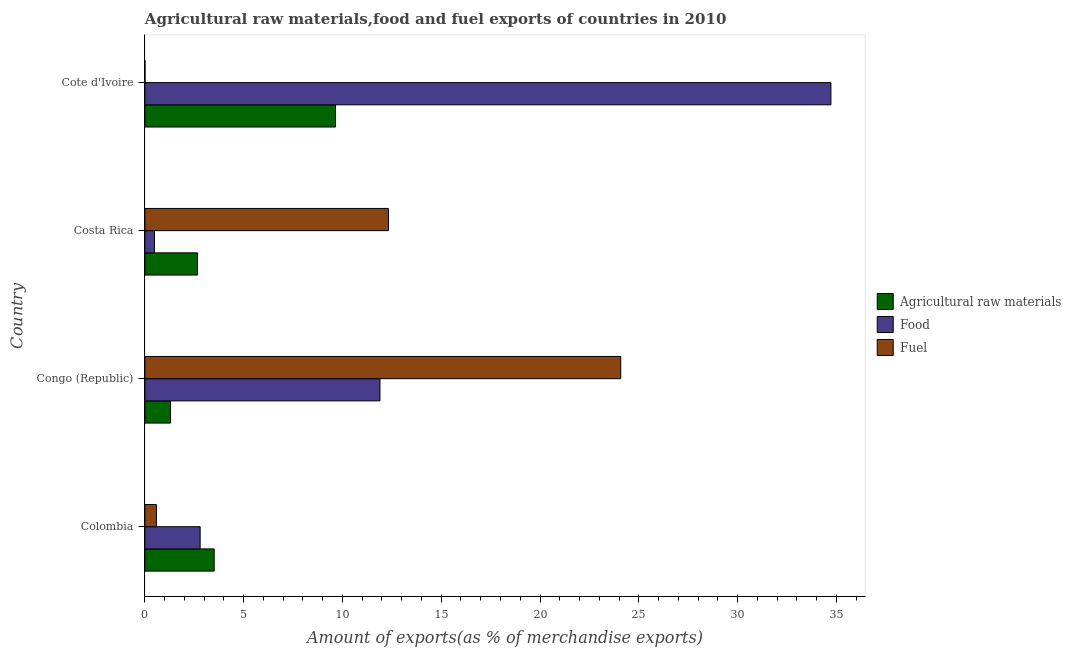How many different coloured bars are there?
Your answer should be compact. 3. Are the number of bars on each tick of the Y-axis equal?
Make the answer very short. Yes. In how many cases, is the number of bars for a given country not equal to the number of legend labels?
Give a very brief answer. 0. What is the percentage of food exports in Congo (Republic)?
Provide a short and direct response. 11.9. Across all countries, what is the maximum percentage of raw materials exports?
Offer a terse response. 9.65. Across all countries, what is the minimum percentage of fuel exports?
Give a very brief answer. 0. In which country was the percentage of raw materials exports maximum?
Your answer should be compact. Cote d'Ivoire. In which country was the percentage of raw materials exports minimum?
Make the answer very short. Congo (Republic). What is the total percentage of food exports in the graph?
Give a very brief answer. 49.9. What is the difference between the percentage of raw materials exports in Colombia and that in Congo (Republic)?
Offer a very short reply. 2.21. What is the difference between the percentage of raw materials exports in Colombia and the percentage of fuel exports in Cote d'Ivoire?
Provide a succinct answer. 3.5. What is the average percentage of fuel exports per country?
Offer a very short reply. 9.25. What is the difference between the percentage of raw materials exports and percentage of fuel exports in Colombia?
Ensure brevity in your answer.  2.92. What is the ratio of the percentage of fuel exports in Colombia to that in Costa Rica?
Offer a terse response. 0.05. Is the percentage of fuel exports in Colombia less than that in Costa Rica?
Provide a short and direct response. Yes. What is the difference between the highest and the second highest percentage of fuel exports?
Ensure brevity in your answer.  11.76. What is the difference between the highest and the lowest percentage of fuel exports?
Your answer should be very brief. 24.08. In how many countries, is the percentage of raw materials exports greater than the average percentage of raw materials exports taken over all countries?
Your response must be concise. 1. What does the 3rd bar from the top in Congo (Republic) represents?
Ensure brevity in your answer.  Agricultural raw materials. What does the 1st bar from the bottom in Costa Rica represents?
Your answer should be very brief. Agricultural raw materials. Is it the case that in every country, the sum of the percentage of raw materials exports and percentage of food exports is greater than the percentage of fuel exports?
Provide a short and direct response. No. How many bars are there?
Your response must be concise. 12. How many countries are there in the graph?
Ensure brevity in your answer.  4. Does the graph contain grids?
Ensure brevity in your answer.  No. How many legend labels are there?
Your answer should be very brief. 3. What is the title of the graph?
Offer a very short reply. Agricultural raw materials,food and fuel exports of countries in 2010. Does "Fuel" appear as one of the legend labels in the graph?
Provide a succinct answer. Yes. What is the label or title of the X-axis?
Your answer should be very brief. Amount of exports(as % of merchandise exports). What is the label or title of the Y-axis?
Your response must be concise. Country. What is the Amount of exports(as % of merchandise exports) in Agricultural raw materials in Colombia?
Ensure brevity in your answer.  3.51. What is the Amount of exports(as % of merchandise exports) of Food in Colombia?
Provide a succinct answer. 2.8. What is the Amount of exports(as % of merchandise exports) in Fuel in Colombia?
Provide a succinct answer. 0.58. What is the Amount of exports(as % of merchandise exports) in Agricultural raw materials in Congo (Republic)?
Provide a short and direct response. 1.3. What is the Amount of exports(as % of merchandise exports) of Food in Congo (Republic)?
Offer a very short reply. 11.9. What is the Amount of exports(as % of merchandise exports) in Fuel in Congo (Republic)?
Ensure brevity in your answer.  24.09. What is the Amount of exports(as % of merchandise exports) in Agricultural raw materials in Costa Rica?
Make the answer very short. 2.66. What is the Amount of exports(as % of merchandise exports) in Food in Costa Rica?
Offer a terse response. 0.48. What is the Amount of exports(as % of merchandise exports) of Fuel in Costa Rica?
Provide a succinct answer. 12.33. What is the Amount of exports(as % of merchandise exports) of Agricultural raw materials in Cote d'Ivoire?
Ensure brevity in your answer.  9.65. What is the Amount of exports(as % of merchandise exports) of Food in Cote d'Ivoire?
Your response must be concise. 34.73. What is the Amount of exports(as % of merchandise exports) of Fuel in Cote d'Ivoire?
Your answer should be compact. 0. Across all countries, what is the maximum Amount of exports(as % of merchandise exports) of Agricultural raw materials?
Ensure brevity in your answer.  9.65. Across all countries, what is the maximum Amount of exports(as % of merchandise exports) of Food?
Keep it short and to the point. 34.73. Across all countries, what is the maximum Amount of exports(as % of merchandise exports) in Fuel?
Your answer should be very brief. 24.09. Across all countries, what is the minimum Amount of exports(as % of merchandise exports) in Agricultural raw materials?
Your answer should be compact. 1.3. Across all countries, what is the minimum Amount of exports(as % of merchandise exports) in Food?
Offer a terse response. 0.48. Across all countries, what is the minimum Amount of exports(as % of merchandise exports) of Fuel?
Provide a short and direct response. 0. What is the total Amount of exports(as % of merchandise exports) in Agricultural raw materials in the graph?
Your answer should be compact. 17.11. What is the total Amount of exports(as % of merchandise exports) in Food in the graph?
Your answer should be compact. 49.9. What is the total Amount of exports(as % of merchandise exports) of Fuel in the graph?
Offer a very short reply. 37. What is the difference between the Amount of exports(as % of merchandise exports) in Agricultural raw materials in Colombia and that in Congo (Republic)?
Your answer should be compact. 2.21. What is the difference between the Amount of exports(as % of merchandise exports) in Food in Colombia and that in Congo (Republic)?
Provide a succinct answer. -9.1. What is the difference between the Amount of exports(as % of merchandise exports) in Fuel in Colombia and that in Congo (Republic)?
Your answer should be very brief. -23.5. What is the difference between the Amount of exports(as % of merchandise exports) in Agricultural raw materials in Colombia and that in Costa Rica?
Provide a short and direct response. 0.84. What is the difference between the Amount of exports(as % of merchandise exports) in Food in Colombia and that in Costa Rica?
Make the answer very short. 2.31. What is the difference between the Amount of exports(as % of merchandise exports) in Fuel in Colombia and that in Costa Rica?
Keep it short and to the point. -11.75. What is the difference between the Amount of exports(as % of merchandise exports) of Agricultural raw materials in Colombia and that in Cote d'Ivoire?
Ensure brevity in your answer.  -6.14. What is the difference between the Amount of exports(as % of merchandise exports) of Food in Colombia and that in Cote d'Ivoire?
Provide a succinct answer. -31.93. What is the difference between the Amount of exports(as % of merchandise exports) in Fuel in Colombia and that in Cote d'Ivoire?
Make the answer very short. 0.58. What is the difference between the Amount of exports(as % of merchandise exports) in Agricultural raw materials in Congo (Republic) and that in Costa Rica?
Provide a succinct answer. -1.36. What is the difference between the Amount of exports(as % of merchandise exports) in Food in Congo (Republic) and that in Costa Rica?
Your response must be concise. 11.42. What is the difference between the Amount of exports(as % of merchandise exports) of Fuel in Congo (Republic) and that in Costa Rica?
Offer a very short reply. 11.76. What is the difference between the Amount of exports(as % of merchandise exports) in Agricultural raw materials in Congo (Republic) and that in Cote d'Ivoire?
Offer a terse response. -8.35. What is the difference between the Amount of exports(as % of merchandise exports) in Food in Congo (Republic) and that in Cote d'Ivoire?
Provide a succinct answer. -22.83. What is the difference between the Amount of exports(as % of merchandise exports) of Fuel in Congo (Republic) and that in Cote d'Ivoire?
Offer a very short reply. 24.08. What is the difference between the Amount of exports(as % of merchandise exports) in Agricultural raw materials in Costa Rica and that in Cote d'Ivoire?
Keep it short and to the point. -6.99. What is the difference between the Amount of exports(as % of merchandise exports) in Food in Costa Rica and that in Cote d'Ivoire?
Give a very brief answer. -34.24. What is the difference between the Amount of exports(as % of merchandise exports) of Fuel in Costa Rica and that in Cote d'Ivoire?
Provide a short and direct response. 12.33. What is the difference between the Amount of exports(as % of merchandise exports) of Agricultural raw materials in Colombia and the Amount of exports(as % of merchandise exports) of Food in Congo (Republic)?
Provide a succinct answer. -8.39. What is the difference between the Amount of exports(as % of merchandise exports) of Agricultural raw materials in Colombia and the Amount of exports(as % of merchandise exports) of Fuel in Congo (Republic)?
Provide a succinct answer. -20.58. What is the difference between the Amount of exports(as % of merchandise exports) in Food in Colombia and the Amount of exports(as % of merchandise exports) in Fuel in Congo (Republic)?
Ensure brevity in your answer.  -21.29. What is the difference between the Amount of exports(as % of merchandise exports) of Agricultural raw materials in Colombia and the Amount of exports(as % of merchandise exports) of Food in Costa Rica?
Your answer should be compact. 3.02. What is the difference between the Amount of exports(as % of merchandise exports) in Agricultural raw materials in Colombia and the Amount of exports(as % of merchandise exports) in Fuel in Costa Rica?
Offer a terse response. -8.82. What is the difference between the Amount of exports(as % of merchandise exports) in Food in Colombia and the Amount of exports(as % of merchandise exports) in Fuel in Costa Rica?
Make the answer very short. -9.53. What is the difference between the Amount of exports(as % of merchandise exports) of Agricultural raw materials in Colombia and the Amount of exports(as % of merchandise exports) of Food in Cote d'Ivoire?
Offer a very short reply. -31.22. What is the difference between the Amount of exports(as % of merchandise exports) in Agricultural raw materials in Colombia and the Amount of exports(as % of merchandise exports) in Fuel in Cote d'Ivoire?
Make the answer very short. 3.5. What is the difference between the Amount of exports(as % of merchandise exports) of Food in Colombia and the Amount of exports(as % of merchandise exports) of Fuel in Cote d'Ivoire?
Provide a short and direct response. 2.79. What is the difference between the Amount of exports(as % of merchandise exports) in Agricultural raw materials in Congo (Republic) and the Amount of exports(as % of merchandise exports) in Food in Costa Rica?
Provide a short and direct response. 0.82. What is the difference between the Amount of exports(as % of merchandise exports) in Agricultural raw materials in Congo (Republic) and the Amount of exports(as % of merchandise exports) in Fuel in Costa Rica?
Make the answer very short. -11.03. What is the difference between the Amount of exports(as % of merchandise exports) in Food in Congo (Republic) and the Amount of exports(as % of merchandise exports) in Fuel in Costa Rica?
Your answer should be very brief. -0.43. What is the difference between the Amount of exports(as % of merchandise exports) of Agricultural raw materials in Congo (Republic) and the Amount of exports(as % of merchandise exports) of Food in Cote d'Ivoire?
Keep it short and to the point. -33.43. What is the difference between the Amount of exports(as % of merchandise exports) of Agricultural raw materials in Congo (Republic) and the Amount of exports(as % of merchandise exports) of Fuel in Cote d'Ivoire?
Provide a succinct answer. 1.3. What is the difference between the Amount of exports(as % of merchandise exports) in Food in Congo (Republic) and the Amount of exports(as % of merchandise exports) in Fuel in Cote d'Ivoire?
Your response must be concise. 11.9. What is the difference between the Amount of exports(as % of merchandise exports) in Agricultural raw materials in Costa Rica and the Amount of exports(as % of merchandise exports) in Food in Cote d'Ivoire?
Your answer should be compact. -32.06. What is the difference between the Amount of exports(as % of merchandise exports) of Agricultural raw materials in Costa Rica and the Amount of exports(as % of merchandise exports) of Fuel in Cote d'Ivoire?
Your answer should be compact. 2.66. What is the difference between the Amount of exports(as % of merchandise exports) of Food in Costa Rica and the Amount of exports(as % of merchandise exports) of Fuel in Cote d'Ivoire?
Keep it short and to the point. 0.48. What is the average Amount of exports(as % of merchandise exports) of Agricultural raw materials per country?
Keep it short and to the point. 4.28. What is the average Amount of exports(as % of merchandise exports) of Food per country?
Your answer should be compact. 12.48. What is the average Amount of exports(as % of merchandise exports) in Fuel per country?
Keep it short and to the point. 9.25. What is the difference between the Amount of exports(as % of merchandise exports) of Agricultural raw materials and Amount of exports(as % of merchandise exports) of Food in Colombia?
Your response must be concise. 0.71. What is the difference between the Amount of exports(as % of merchandise exports) of Agricultural raw materials and Amount of exports(as % of merchandise exports) of Fuel in Colombia?
Offer a very short reply. 2.92. What is the difference between the Amount of exports(as % of merchandise exports) in Food and Amount of exports(as % of merchandise exports) in Fuel in Colombia?
Provide a succinct answer. 2.21. What is the difference between the Amount of exports(as % of merchandise exports) of Agricultural raw materials and Amount of exports(as % of merchandise exports) of Fuel in Congo (Republic)?
Provide a short and direct response. -22.79. What is the difference between the Amount of exports(as % of merchandise exports) in Food and Amount of exports(as % of merchandise exports) in Fuel in Congo (Republic)?
Your answer should be very brief. -12.19. What is the difference between the Amount of exports(as % of merchandise exports) in Agricultural raw materials and Amount of exports(as % of merchandise exports) in Food in Costa Rica?
Give a very brief answer. 2.18. What is the difference between the Amount of exports(as % of merchandise exports) in Agricultural raw materials and Amount of exports(as % of merchandise exports) in Fuel in Costa Rica?
Give a very brief answer. -9.67. What is the difference between the Amount of exports(as % of merchandise exports) in Food and Amount of exports(as % of merchandise exports) in Fuel in Costa Rica?
Give a very brief answer. -11.84. What is the difference between the Amount of exports(as % of merchandise exports) of Agricultural raw materials and Amount of exports(as % of merchandise exports) of Food in Cote d'Ivoire?
Your answer should be very brief. -25.08. What is the difference between the Amount of exports(as % of merchandise exports) in Agricultural raw materials and Amount of exports(as % of merchandise exports) in Fuel in Cote d'Ivoire?
Keep it short and to the point. 9.65. What is the difference between the Amount of exports(as % of merchandise exports) of Food and Amount of exports(as % of merchandise exports) of Fuel in Cote d'Ivoire?
Keep it short and to the point. 34.72. What is the ratio of the Amount of exports(as % of merchandise exports) in Agricultural raw materials in Colombia to that in Congo (Republic)?
Your answer should be compact. 2.7. What is the ratio of the Amount of exports(as % of merchandise exports) of Food in Colombia to that in Congo (Republic)?
Provide a succinct answer. 0.23. What is the ratio of the Amount of exports(as % of merchandise exports) in Fuel in Colombia to that in Congo (Republic)?
Give a very brief answer. 0.02. What is the ratio of the Amount of exports(as % of merchandise exports) of Agricultural raw materials in Colombia to that in Costa Rica?
Offer a very short reply. 1.32. What is the ratio of the Amount of exports(as % of merchandise exports) in Food in Colombia to that in Costa Rica?
Offer a terse response. 5.79. What is the ratio of the Amount of exports(as % of merchandise exports) in Fuel in Colombia to that in Costa Rica?
Provide a short and direct response. 0.05. What is the ratio of the Amount of exports(as % of merchandise exports) of Agricultural raw materials in Colombia to that in Cote d'Ivoire?
Make the answer very short. 0.36. What is the ratio of the Amount of exports(as % of merchandise exports) of Food in Colombia to that in Cote d'Ivoire?
Offer a terse response. 0.08. What is the ratio of the Amount of exports(as % of merchandise exports) in Fuel in Colombia to that in Cote d'Ivoire?
Your response must be concise. 242.1. What is the ratio of the Amount of exports(as % of merchandise exports) of Agricultural raw materials in Congo (Republic) to that in Costa Rica?
Provide a short and direct response. 0.49. What is the ratio of the Amount of exports(as % of merchandise exports) in Food in Congo (Republic) to that in Costa Rica?
Offer a very short reply. 24.64. What is the ratio of the Amount of exports(as % of merchandise exports) in Fuel in Congo (Republic) to that in Costa Rica?
Ensure brevity in your answer.  1.95. What is the ratio of the Amount of exports(as % of merchandise exports) in Agricultural raw materials in Congo (Republic) to that in Cote d'Ivoire?
Make the answer very short. 0.13. What is the ratio of the Amount of exports(as % of merchandise exports) of Food in Congo (Republic) to that in Cote d'Ivoire?
Make the answer very short. 0.34. What is the ratio of the Amount of exports(as % of merchandise exports) of Fuel in Congo (Republic) to that in Cote d'Ivoire?
Provide a short and direct response. 1.00e+04. What is the ratio of the Amount of exports(as % of merchandise exports) in Agricultural raw materials in Costa Rica to that in Cote d'Ivoire?
Your answer should be very brief. 0.28. What is the ratio of the Amount of exports(as % of merchandise exports) in Food in Costa Rica to that in Cote d'Ivoire?
Offer a very short reply. 0.01. What is the ratio of the Amount of exports(as % of merchandise exports) of Fuel in Costa Rica to that in Cote d'Ivoire?
Offer a very short reply. 5127.7. What is the difference between the highest and the second highest Amount of exports(as % of merchandise exports) of Agricultural raw materials?
Make the answer very short. 6.14. What is the difference between the highest and the second highest Amount of exports(as % of merchandise exports) of Food?
Offer a very short reply. 22.83. What is the difference between the highest and the second highest Amount of exports(as % of merchandise exports) of Fuel?
Your answer should be very brief. 11.76. What is the difference between the highest and the lowest Amount of exports(as % of merchandise exports) in Agricultural raw materials?
Offer a terse response. 8.35. What is the difference between the highest and the lowest Amount of exports(as % of merchandise exports) in Food?
Your answer should be compact. 34.24. What is the difference between the highest and the lowest Amount of exports(as % of merchandise exports) in Fuel?
Provide a succinct answer. 24.08. 